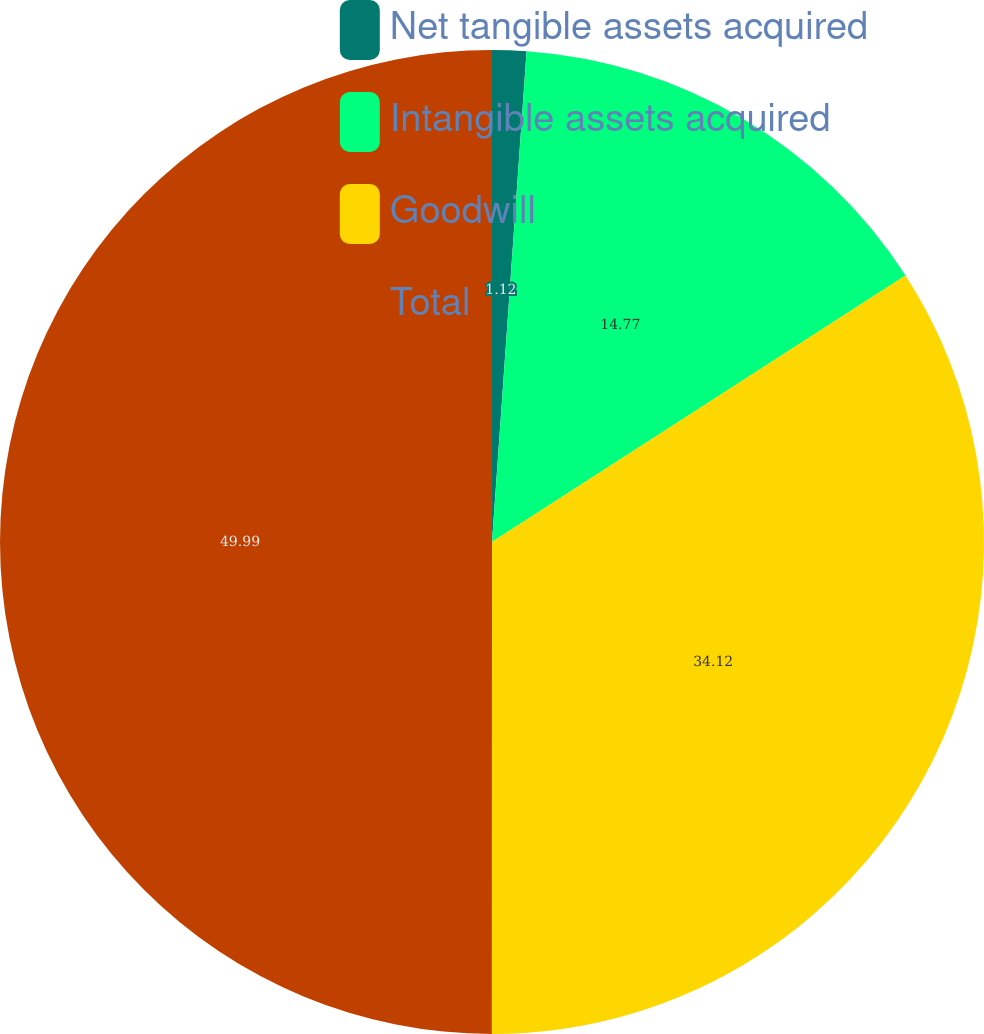Convert chart to OTSL. <chart><loc_0><loc_0><loc_500><loc_500><pie_chart><fcel>Net tangible assets acquired<fcel>Intangible assets acquired<fcel>Goodwill<fcel>Total<nl><fcel>1.12%<fcel>14.77%<fcel>34.12%<fcel>50.0%<nl></chart> 